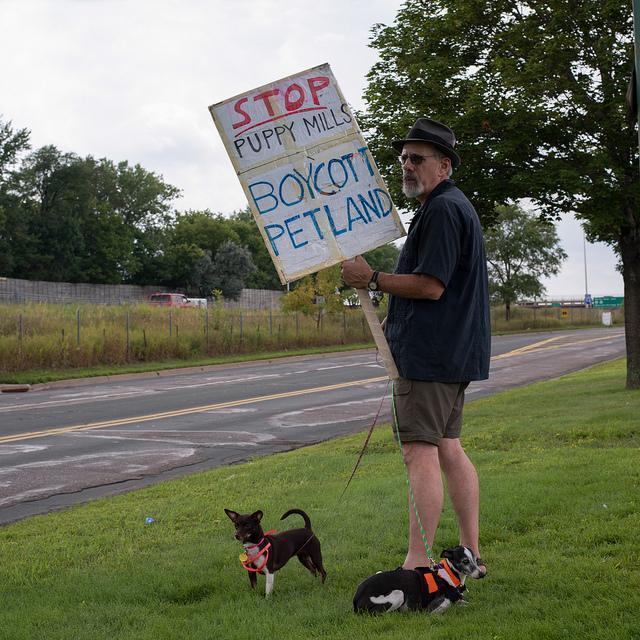What sort of life does this man advocate for?
Select the accurate answer and provide explanation: 'Answer: answer
Rationale: rationale.'
Options: Merchants, canines, felines, people. Answer: canines.
Rationale: The sign refers to young dogs being bred by irresponsible owners for quick money. 